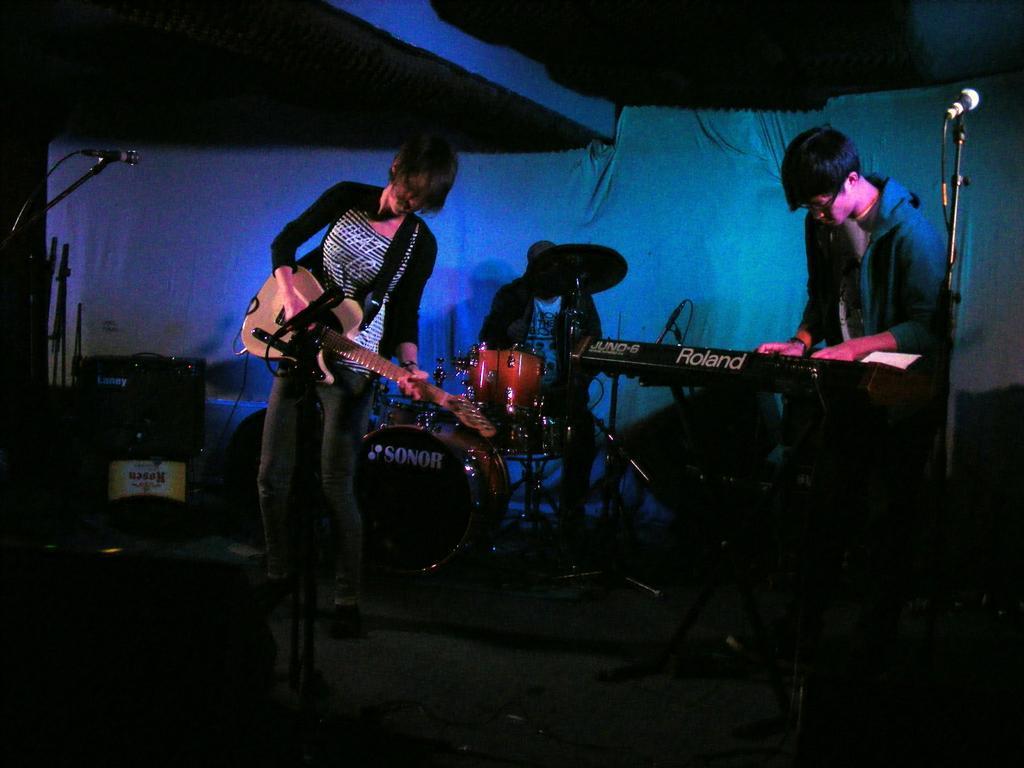Can you describe this image briefly? In this picture there are three members sitting. Two of them were standing. Everybody is having a musical instrument in front of them. All of them were playing those musical instruments. In the right there is a microphone. We can observe a cloth in the background. 